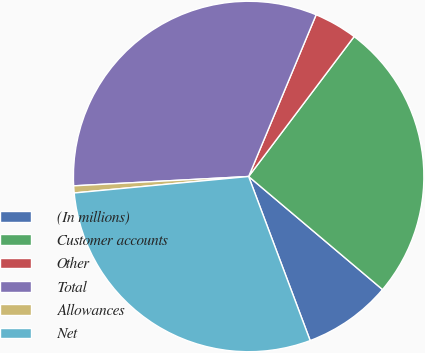Convert chart to OTSL. <chart><loc_0><loc_0><loc_500><loc_500><pie_chart><fcel>(In millions)<fcel>Customer accounts<fcel>Other<fcel>Total<fcel>Allowances<fcel>Net<nl><fcel>8.13%<fcel>25.88%<fcel>3.99%<fcel>32.14%<fcel>0.65%<fcel>29.21%<nl></chart> 